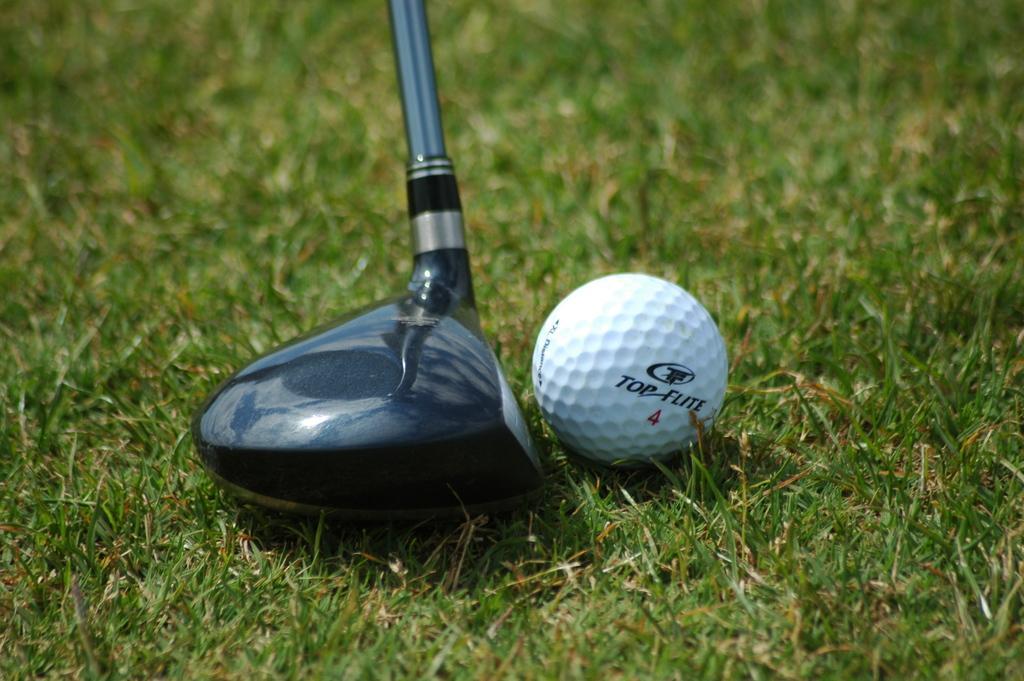Please provide a concise description of this image. In this image we can see a grassy land. There is a golf ball and a golf stick in the image. 